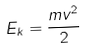Convert formula to latex. <formula><loc_0><loc_0><loc_500><loc_500>E _ { k } = \frac { m v ^ { 2 } } { 2 }</formula> 